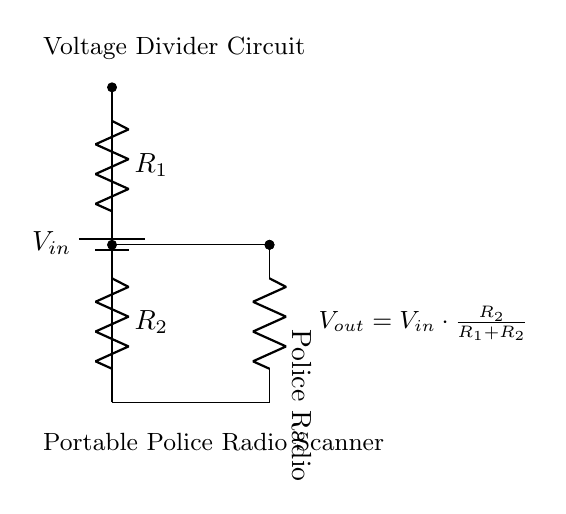What type of circuit is this? This is a voltage divider circuit, which is designed to divide the input voltage into a lower voltage output proportional to the resistor values.
Answer: Voltage Divider What are the two resistors labeled in the diagram? In the diagram, the two resistors are labeled as R1 and R2. Resistors are essential components in a voltage divider as they determine the output voltage level.
Answer: R1, R2 How is the output voltage calculated? The output voltage (Vout) is calculated using the formula Vout equals Vin multiplied by R2 divided by the sum of R1 and R2. This relation gives the voltage that can be extracted across R2.
Answer: Vout = Vin * R2 / (R1 + R2) What component powers the portable police radio? The component that powers the portable police radio in the circuit is R2, which receives the output voltage from the voltage divider to supply power to the radio.
Answer: R2 What is the purpose of the voltage divider in this circuit? The purpose of the voltage divider is to reduce the input voltage (Vin) to a lower level that is suitable for powering the portable police radio scanner, ensuring it operates safely and effectively.
Answer: Reduce voltage for radio What is the input voltage represented in the circuit? The input voltage (Vin) is the voltage supplied by the battery, which is shown at the top of the circuit diagram. This voltage is what the divider will reduce for the radio.
Answer: Vin 